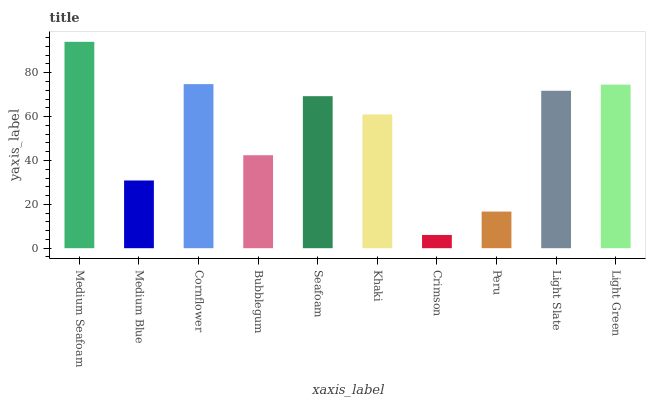Is Crimson the minimum?
Answer yes or no. Yes. Is Medium Seafoam the maximum?
Answer yes or no. Yes. Is Medium Blue the minimum?
Answer yes or no. No. Is Medium Blue the maximum?
Answer yes or no. No. Is Medium Seafoam greater than Medium Blue?
Answer yes or no. Yes. Is Medium Blue less than Medium Seafoam?
Answer yes or no. Yes. Is Medium Blue greater than Medium Seafoam?
Answer yes or no. No. Is Medium Seafoam less than Medium Blue?
Answer yes or no. No. Is Seafoam the high median?
Answer yes or no. Yes. Is Khaki the low median?
Answer yes or no. Yes. Is Light Slate the high median?
Answer yes or no. No. Is Bubblegum the low median?
Answer yes or no. No. 